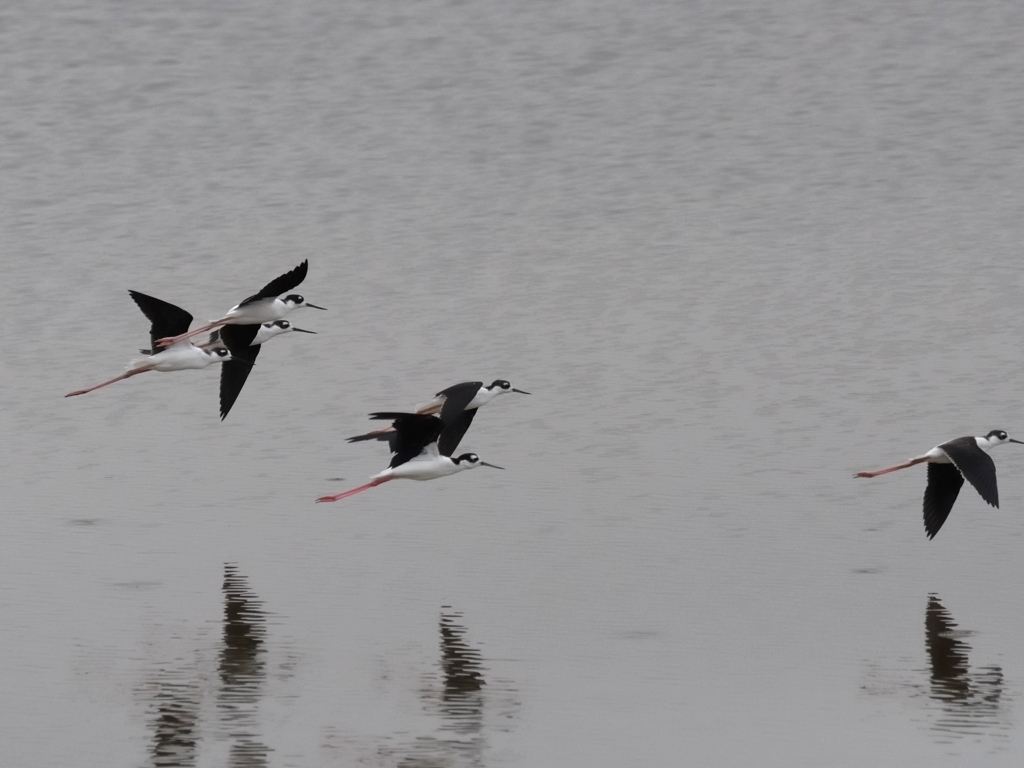How accurate is the focus of this image?
A. Out of focus
B. Blurred
C. Accurate
D. Slightly off The focus in this image is quite sharp, capturing fine details of the birds in flight. Each bird's feathers and color patterns are clear, and the reflection on the water's surface is well-defined. Hence, the most accurate description of the focus is option C, 'Accurate'. 